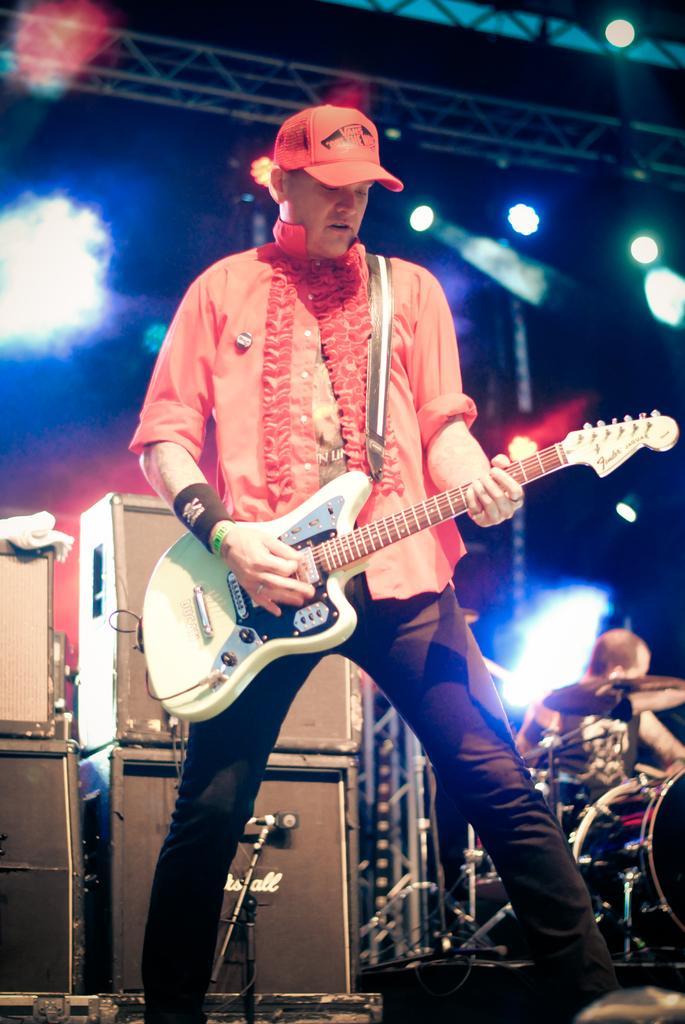How would you summarize this image in a sentence or two? In this picture we can see a man holding a guitar and the man is standing on the stage. Behind the man there is another person sitting. On the stage there are some musical instruments. Behind the people there are lights and a truss. 